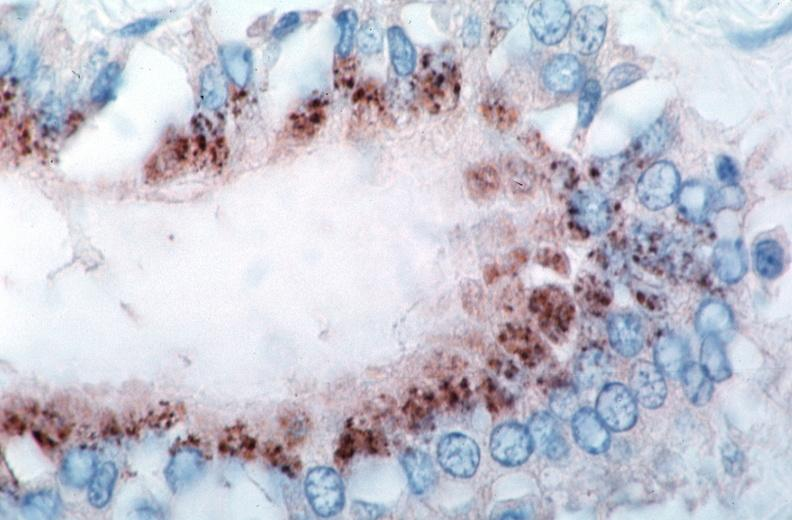what is rocky mountain spotted?
Answer the question using a single word or phrase. Fever 